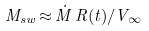<formula> <loc_0><loc_0><loc_500><loc_500>M _ { s w } \, { \approx } \, { \dot { M } } \, R ( t ) / V _ { \infty }</formula> 